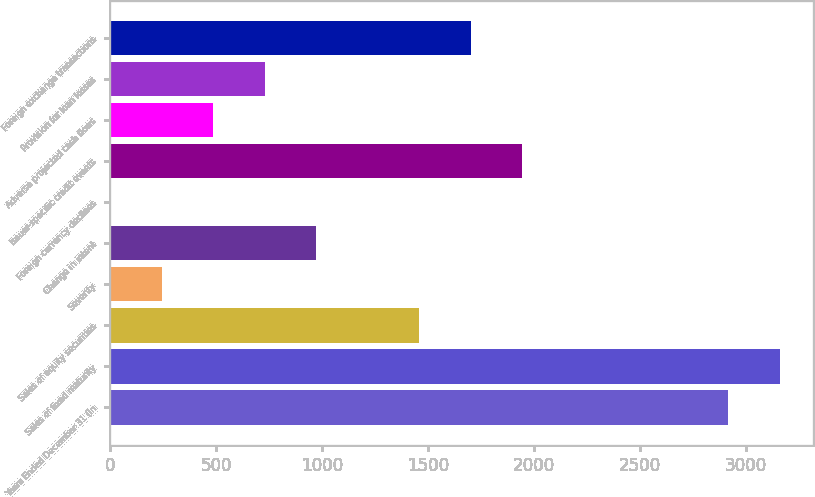Convert chart. <chart><loc_0><loc_0><loc_500><loc_500><bar_chart><fcel>Years Ended December 31 (in<fcel>Sales of fixed maturity<fcel>Sales of equity securities<fcel>Severity<fcel>Change in intent<fcel>Foreign currency declines<fcel>Issuer-specific credit events<fcel>Adverse projected cash flows<fcel>Provision for loan losses<fcel>Foreign exchange transactions<nl><fcel>2918.2<fcel>3161.3<fcel>1459.6<fcel>244.1<fcel>973.4<fcel>1<fcel>1945.8<fcel>487.2<fcel>730.3<fcel>1702.7<nl></chart> 